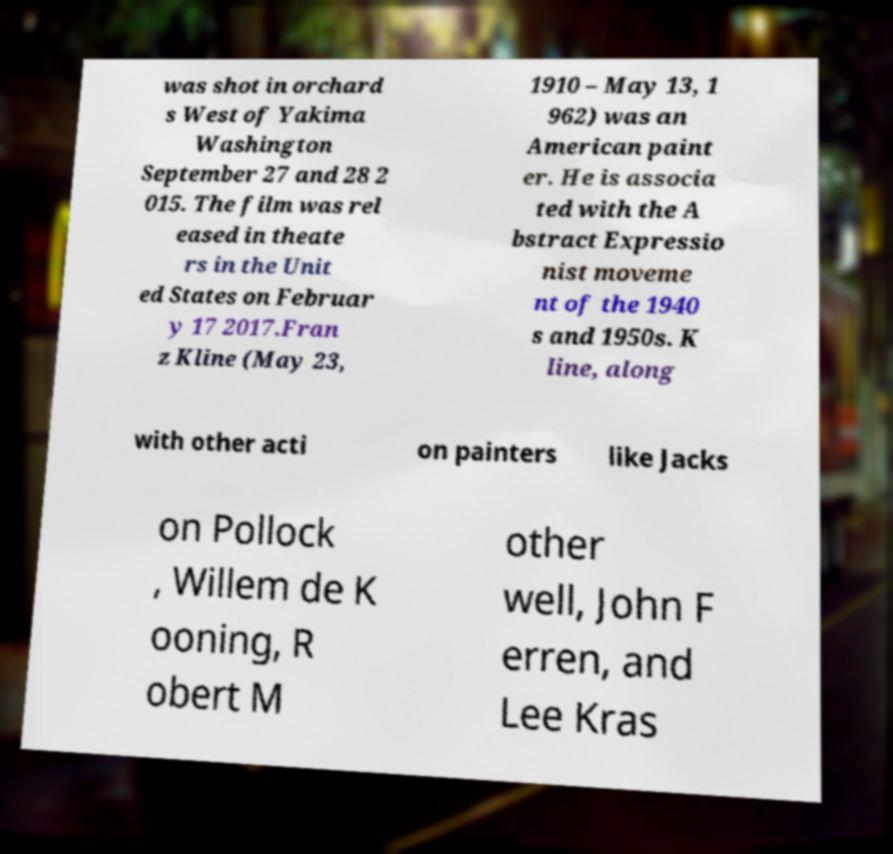Could you extract and type out the text from this image? was shot in orchard s West of Yakima Washington September 27 and 28 2 015. The film was rel eased in theate rs in the Unit ed States on Februar y 17 2017.Fran z Kline (May 23, 1910 – May 13, 1 962) was an American paint er. He is associa ted with the A bstract Expressio nist moveme nt of the 1940 s and 1950s. K line, along with other acti on painters like Jacks on Pollock , Willem de K ooning, R obert M other well, John F erren, and Lee Kras 